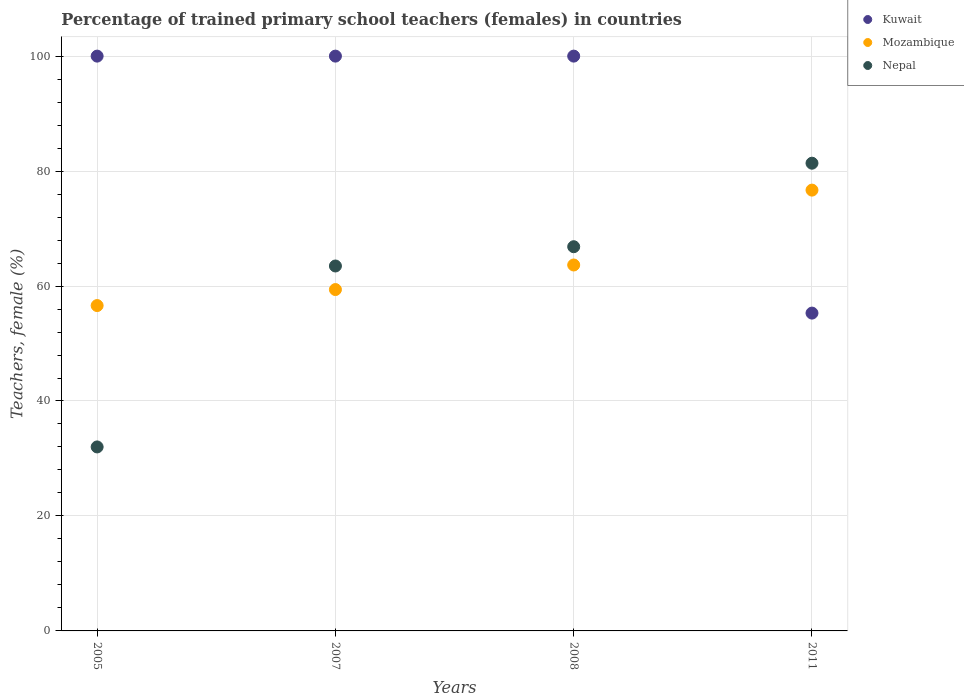How many different coloured dotlines are there?
Your answer should be compact. 3. What is the percentage of trained primary school teachers (females) in Mozambique in 2005?
Ensure brevity in your answer.  56.6. Across all years, what is the maximum percentage of trained primary school teachers (females) in Nepal?
Your answer should be very brief. 81.37. Across all years, what is the minimum percentage of trained primary school teachers (females) in Mozambique?
Your response must be concise. 56.6. In which year was the percentage of trained primary school teachers (females) in Mozambique maximum?
Provide a succinct answer. 2011. What is the total percentage of trained primary school teachers (females) in Mozambique in the graph?
Offer a terse response. 256.34. What is the difference between the percentage of trained primary school teachers (females) in Mozambique in 2007 and that in 2011?
Make the answer very short. -17.3. What is the difference between the percentage of trained primary school teachers (females) in Nepal in 2005 and the percentage of trained primary school teachers (females) in Kuwait in 2007?
Offer a terse response. -67.99. What is the average percentage of trained primary school teachers (females) in Mozambique per year?
Offer a very short reply. 64.09. In the year 2008, what is the difference between the percentage of trained primary school teachers (females) in Mozambique and percentage of trained primary school teachers (females) in Kuwait?
Make the answer very short. -36.34. What is the ratio of the percentage of trained primary school teachers (females) in Nepal in 2008 to that in 2011?
Ensure brevity in your answer.  0.82. Is the percentage of trained primary school teachers (females) in Kuwait in 2005 less than that in 2007?
Ensure brevity in your answer.  No. Is the difference between the percentage of trained primary school teachers (females) in Mozambique in 2007 and 2008 greater than the difference between the percentage of trained primary school teachers (females) in Kuwait in 2007 and 2008?
Make the answer very short. No. What is the difference between the highest and the second highest percentage of trained primary school teachers (females) in Kuwait?
Offer a very short reply. 0. What is the difference between the highest and the lowest percentage of trained primary school teachers (females) in Nepal?
Keep it short and to the point. 49.36. In how many years, is the percentage of trained primary school teachers (females) in Kuwait greater than the average percentage of trained primary school teachers (females) in Kuwait taken over all years?
Ensure brevity in your answer.  3. Is it the case that in every year, the sum of the percentage of trained primary school teachers (females) in Nepal and percentage of trained primary school teachers (females) in Mozambique  is greater than the percentage of trained primary school teachers (females) in Kuwait?
Keep it short and to the point. No. Does the percentage of trained primary school teachers (females) in Nepal monotonically increase over the years?
Ensure brevity in your answer.  Yes. Is the percentage of trained primary school teachers (females) in Mozambique strictly greater than the percentage of trained primary school teachers (females) in Nepal over the years?
Provide a succinct answer. No. Is the percentage of trained primary school teachers (females) in Nepal strictly less than the percentage of trained primary school teachers (females) in Kuwait over the years?
Your response must be concise. No. How many years are there in the graph?
Your response must be concise. 4. Are the values on the major ticks of Y-axis written in scientific E-notation?
Make the answer very short. No. Does the graph contain grids?
Your response must be concise. Yes. What is the title of the graph?
Make the answer very short. Percentage of trained primary school teachers (females) in countries. Does "Hungary" appear as one of the legend labels in the graph?
Provide a succinct answer. No. What is the label or title of the X-axis?
Your answer should be compact. Years. What is the label or title of the Y-axis?
Provide a succinct answer. Teachers, female (%). What is the Teachers, female (%) in Kuwait in 2005?
Your answer should be compact. 100. What is the Teachers, female (%) in Mozambique in 2005?
Offer a very short reply. 56.6. What is the Teachers, female (%) in Nepal in 2005?
Ensure brevity in your answer.  32.01. What is the Teachers, female (%) of Mozambique in 2007?
Offer a very short reply. 59.39. What is the Teachers, female (%) in Nepal in 2007?
Give a very brief answer. 63.49. What is the Teachers, female (%) in Kuwait in 2008?
Your response must be concise. 100. What is the Teachers, female (%) in Mozambique in 2008?
Give a very brief answer. 63.66. What is the Teachers, female (%) of Nepal in 2008?
Provide a succinct answer. 66.84. What is the Teachers, female (%) of Kuwait in 2011?
Your answer should be very brief. 55.29. What is the Teachers, female (%) of Mozambique in 2011?
Offer a terse response. 76.69. What is the Teachers, female (%) of Nepal in 2011?
Offer a terse response. 81.37. Across all years, what is the maximum Teachers, female (%) of Mozambique?
Keep it short and to the point. 76.69. Across all years, what is the maximum Teachers, female (%) in Nepal?
Make the answer very short. 81.37. Across all years, what is the minimum Teachers, female (%) of Kuwait?
Provide a succinct answer. 55.29. Across all years, what is the minimum Teachers, female (%) of Mozambique?
Provide a succinct answer. 56.6. Across all years, what is the minimum Teachers, female (%) of Nepal?
Make the answer very short. 32.01. What is the total Teachers, female (%) in Kuwait in the graph?
Your answer should be compact. 355.29. What is the total Teachers, female (%) in Mozambique in the graph?
Provide a short and direct response. 256.34. What is the total Teachers, female (%) in Nepal in the graph?
Offer a terse response. 243.71. What is the difference between the Teachers, female (%) in Mozambique in 2005 and that in 2007?
Give a very brief answer. -2.78. What is the difference between the Teachers, female (%) of Nepal in 2005 and that in 2007?
Your answer should be compact. -31.48. What is the difference between the Teachers, female (%) in Kuwait in 2005 and that in 2008?
Make the answer very short. 0. What is the difference between the Teachers, female (%) in Mozambique in 2005 and that in 2008?
Your response must be concise. -7.06. What is the difference between the Teachers, female (%) of Nepal in 2005 and that in 2008?
Give a very brief answer. -34.83. What is the difference between the Teachers, female (%) in Kuwait in 2005 and that in 2011?
Ensure brevity in your answer.  44.71. What is the difference between the Teachers, female (%) of Mozambique in 2005 and that in 2011?
Your response must be concise. -20.08. What is the difference between the Teachers, female (%) of Nepal in 2005 and that in 2011?
Offer a terse response. -49.36. What is the difference between the Teachers, female (%) in Mozambique in 2007 and that in 2008?
Provide a succinct answer. -4.27. What is the difference between the Teachers, female (%) in Nepal in 2007 and that in 2008?
Your response must be concise. -3.35. What is the difference between the Teachers, female (%) in Kuwait in 2007 and that in 2011?
Provide a short and direct response. 44.71. What is the difference between the Teachers, female (%) in Mozambique in 2007 and that in 2011?
Give a very brief answer. -17.3. What is the difference between the Teachers, female (%) in Nepal in 2007 and that in 2011?
Make the answer very short. -17.88. What is the difference between the Teachers, female (%) in Kuwait in 2008 and that in 2011?
Ensure brevity in your answer.  44.71. What is the difference between the Teachers, female (%) of Mozambique in 2008 and that in 2011?
Give a very brief answer. -13.03. What is the difference between the Teachers, female (%) in Nepal in 2008 and that in 2011?
Ensure brevity in your answer.  -14.53. What is the difference between the Teachers, female (%) of Kuwait in 2005 and the Teachers, female (%) of Mozambique in 2007?
Your response must be concise. 40.61. What is the difference between the Teachers, female (%) of Kuwait in 2005 and the Teachers, female (%) of Nepal in 2007?
Your response must be concise. 36.51. What is the difference between the Teachers, female (%) in Mozambique in 2005 and the Teachers, female (%) in Nepal in 2007?
Provide a succinct answer. -6.89. What is the difference between the Teachers, female (%) of Kuwait in 2005 and the Teachers, female (%) of Mozambique in 2008?
Offer a very short reply. 36.34. What is the difference between the Teachers, female (%) of Kuwait in 2005 and the Teachers, female (%) of Nepal in 2008?
Offer a terse response. 33.16. What is the difference between the Teachers, female (%) in Mozambique in 2005 and the Teachers, female (%) in Nepal in 2008?
Give a very brief answer. -10.24. What is the difference between the Teachers, female (%) in Kuwait in 2005 and the Teachers, female (%) in Mozambique in 2011?
Your response must be concise. 23.31. What is the difference between the Teachers, female (%) in Kuwait in 2005 and the Teachers, female (%) in Nepal in 2011?
Offer a very short reply. 18.63. What is the difference between the Teachers, female (%) in Mozambique in 2005 and the Teachers, female (%) in Nepal in 2011?
Ensure brevity in your answer.  -24.77. What is the difference between the Teachers, female (%) in Kuwait in 2007 and the Teachers, female (%) in Mozambique in 2008?
Give a very brief answer. 36.34. What is the difference between the Teachers, female (%) of Kuwait in 2007 and the Teachers, female (%) of Nepal in 2008?
Your response must be concise. 33.16. What is the difference between the Teachers, female (%) of Mozambique in 2007 and the Teachers, female (%) of Nepal in 2008?
Provide a short and direct response. -7.45. What is the difference between the Teachers, female (%) of Kuwait in 2007 and the Teachers, female (%) of Mozambique in 2011?
Your answer should be compact. 23.31. What is the difference between the Teachers, female (%) of Kuwait in 2007 and the Teachers, female (%) of Nepal in 2011?
Offer a terse response. 18.63. What is the difference between the Teachers, female (%) of Mozambique in 2007 and the Teachers, female (%) of Nepal in 2011?
Provide a succinct answer. -21.98. What is the difference between the Teachers, female (%) of Kuwait in 2008 and the Teachers, female (%) of Mozambique in 2011?
Make the answer very short. 23.31. What is the difference between the Teachers, female (%) of Kuwait in 2008 and the Teachers, female (%) of Nepal in 2011?
Provide a succinct answer. 18.63. What is the difference between the Teachers, female (%) of Mozambique in 2008 and the Teachers, female (%) of Nepal in 2011?
Ensure brevity in your answer.  -17.71. What is the average Teachers, female (%) of Kuwait per year?
Offer a very short reply. 88.82. What is the average Teachers, female (%) of Mozambique per year?
Provide a short and direct response. 64.09. What is the average Teachers, female (%) of Nepal per year?
Keep it short and to the point. 60.93. In the year 2005, what is the difference between the Teachers, female (%) of Kuwait and Teachers, female (%) of Mozambique?
Your answer should be very brief. 43.4. In the year 2005, what is the difference between the Teachers, female (%) of Kuwait and Teachers, female (%) of Nepal?
Give a very brief answer. 67.99. In the year 2005, what is the difference between the Teachers, female (%) in Mozambique and Teachers, female (%) in Nepal?
Offer a very short reply. 24.6. In the year 2007, what is the difference between the Teachers, female (%) of Kuwait and Teachers, female (%) of Mozambique?
Provide a succinct answer. 40.61. In the year 2007, what is the difference between the Teachers, female (%) in Kuwait and Teachers, female (%) in Nepal?
Offer a very short reply. 36.51. In the year 2007, what is the difference between the Teachers, female (%) of Mozambique and Teachers, female (%) of Nepal?
Offer a very short reply. -4.1. In the year 2008, what is the difference between the Teachers, female (%) of Kuwait and Teachers, female (%) of Mozambique?
Ensure brevity in your answer.  36.34. In the year 2008, what is the difference between the Teachers, female (%) of Kuwait and Teachers, female (%) of Nepal?
Keep it short and to the point. 33.16. In the year 2008, what is the difference between the Teachers, female (%) of Mozambique and Teachers, female (%) of Nepal?
Provide a short and direct response. -3.18. In the year 2011, what is the difference between the Teachers, female (%) in Kuwait and Teachers, female (%) in Mozambique?
Keep it short and to the point. -21.4. In the year 2011, what is the difference between the Teachers, female (%) in Kuwait and Teachers, female (%) in Nepal?
Give a very brief answer. -26.08. In the year 2011, what is the difference between the Teachers, female (%) of Mozambique and Teachers, female (%) of Nepal?
Offer a very short reply. -4.68. What is the ratio of the Teachers, female (%) in Mozambique in 2005 to that in 2007?
Keep it short and to the point. 0.95. What is the ratio of the Teachers, female (%) of Nepal in 2005 to that in 2007?
Your response must be concise. 0.5. What is the ratio of the Teachers, female (%) of Kuwait in 2005 to that in 2008?
Give a very brief answer. 1. What is the ratio of the Teachers, female (%) in Mozambique in 2005 to that in 2008?
Offer a terse response. 0.89. What is the ratio of the Teachers, female (%) in Nepal in 2005 to that in 2008?
Your response must be concise. 0.48. What is the ratio of the Teachers, female (%) of Kuwait in 2005 to that in 2011?
Provide a short and direct response. 1.81. What is the ratio of the Teachers, female (%) in Mozambique in 2005 to that in 2011?
Make the answer very short. 0.74. What is the ratio of the Teachers, female (%) in Nepal in 2005 to that in 2011?
Ensure brevity in your answer.  0.39. What is the ratio of the Teachers, female (%) of Kuwait in 2007 to that in 2008?
Your answer should be compact. 1. What is the ratio of the Teachers, female (%) in Mozambique in 2007 to that in 2008?
Your answer should be very brief. 0.93. What is the ratio of the Teachers, female (%) of Nepal in 2007 to that in 2008?
Keep it short and to the point. 0.95. What is the ratio of the Teachers, female (%) of Kuwait in 2007 to that in 2011?
Make the answer very short. 1.81. What is the ratio of the Teachers, female (%) of Mozambique in 2007 to that in 2011?
Give a very brief answer. 0.77. What is the ratio of the Teachers, female (%) in Nepal in 2007 to that in 2011?
Your response must be concise. 0.78. What is the ratio of the Teachers, female (%) of Kuwait in 2008 to that in 2011?
Provide a succinct answer. 1.81. What is the ratio of the Teachers, female (%) in Mozambique in 2008 to that in 2011?
Offer a very short reply. 0.83. What is the ratio of the Teachers, female (%) of Nepal in 2008 to that in 2011?
Your answer should be compact. 0.82. What is the difference between the highest and the second highest Teachers, female (%) in Kuwait?
Give a very brief answer. 0. What is the difference between the highest and the second highest Teachers, female (%) of Mozambique?
Give a very brief answer. 13.03. What is the difference between the highest and the second highest Teachers, female (%) of Nepal?
Make the answer very short. 14.53. What is the difference between the highest and the lowest Teachers, female (%) in Kuwait?
Make the answer very short. 44.71. What is the difference between the highest and the lowest Teachers, female (%) of Mozambique?
Ensure brevity in your answer.  20.08. What is the difference between the highest and the lowest Teachers, female (%) of Nepal?
Make the answer very short. 49.36. 